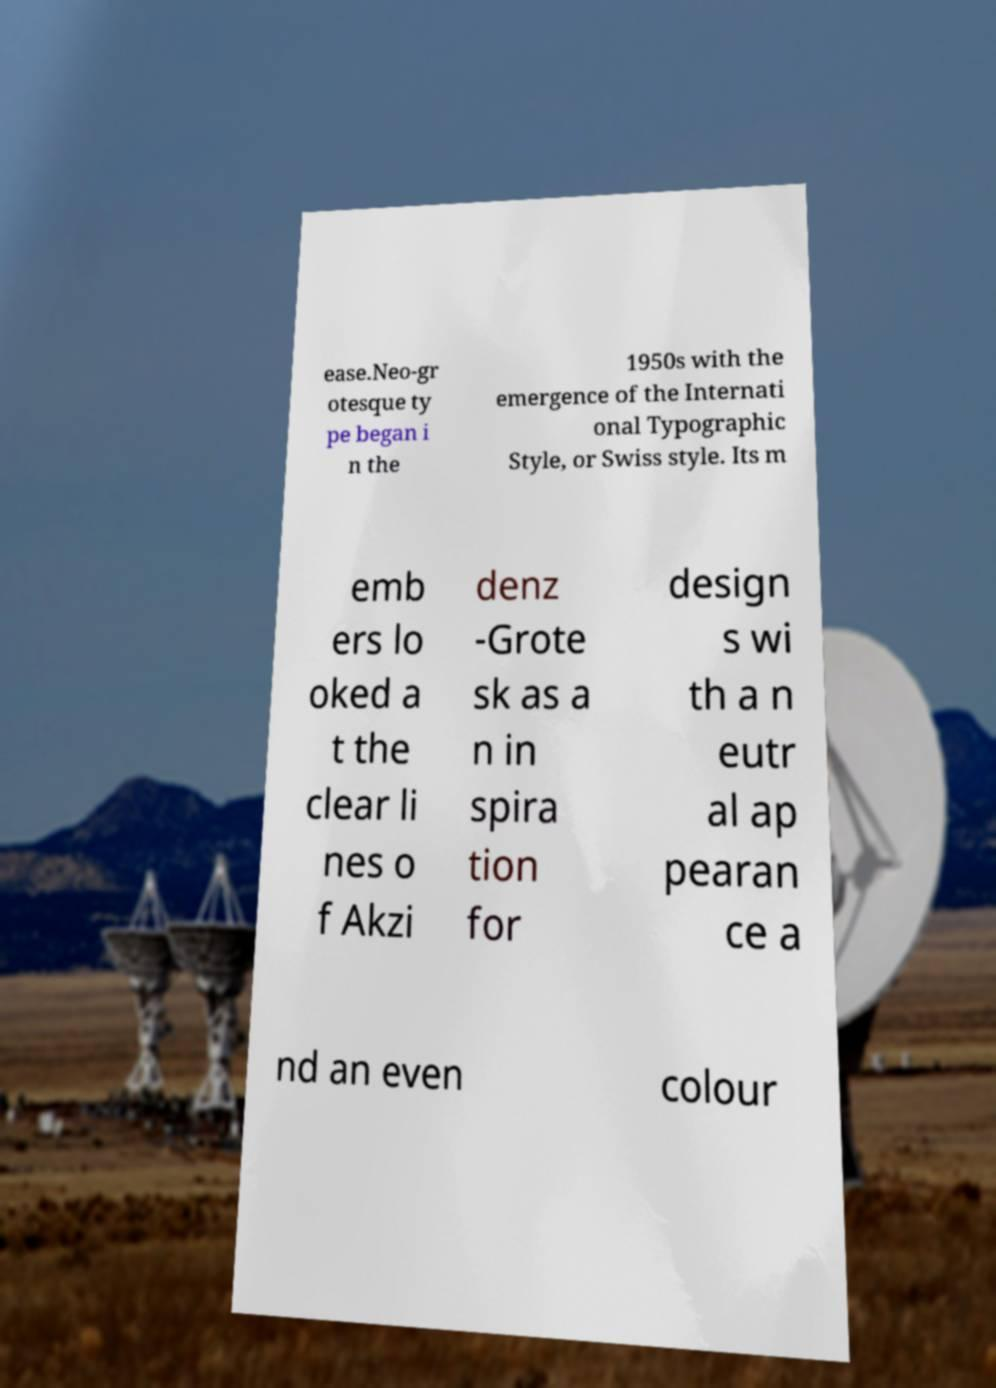Please identify and transcribe the text found in this image. ease.Neo-gr otesque ty pe began i n the 1950s with the emergence of the Internati onal Typographic Style, or Swiss style. Its m emb ers lo oked a t the clear li nes o f Akzi denz -Grote sk as a n in spira tion for design s wi th a n eutr al ap pearan ce a nd an even colour 